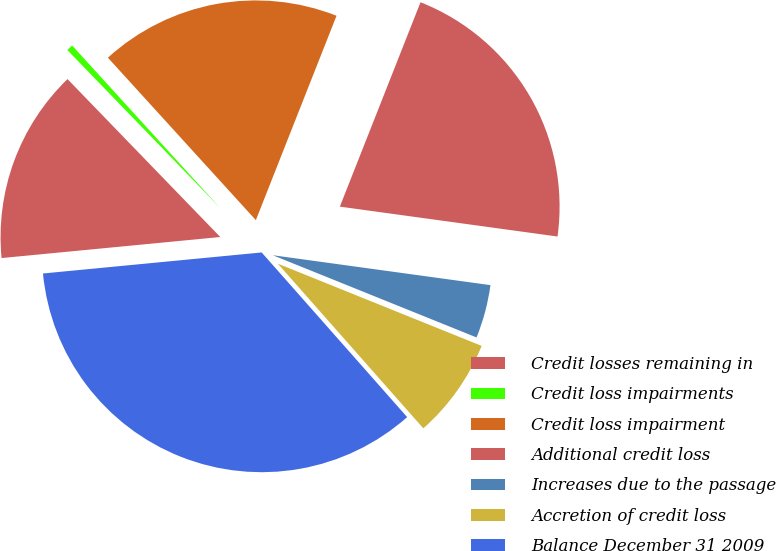Convert chart. <chart><loc_0><loc_0><loc_500><loc_500><pie_chart><fcel>Credit losses remaining in<fcel>Credit loss impairments<fcel>Credit loss impairment<fcel>Additional credit loss<fcel>Increases due to the passage<fcel>Accretion of credit loss<fcel>Balance December 31 2009<nl><fcel>14.29%<fcel>0.48%<fcel>17.74%<fcel>21.19%<fcel>3.93%<fcel>7.38%<fcel>34.99%<nl></chart> 